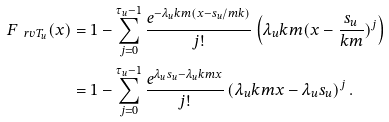<formula> <loc_0><loc_0><loc_500><loc_500>F _ { \ r v T _ { u } } ( x ) & = 1 - \sum _ { j = 0 } ^ { \tau _ { u } - 1 } \frac { e ^ { - \lambda _ { u } k m ( x - s _ { u } / m k ) } } { j ! } \left ( \lambda _ { u } k m ( x - \frac { s _ { u } } { k m } ) ^ { j } \right ) \\ & = 1 - \sum _ { j = 0 } ^ { \tau _ { u } - 1 } \frac { e ^ { \lambda _ { u } s _ { u } - \lambda _ { u } k m x } } { j ! } \left ( \lambda _ { u } k m x - \lambda _ { u } s _ { u } \right ) ^ { j } .</formula> 